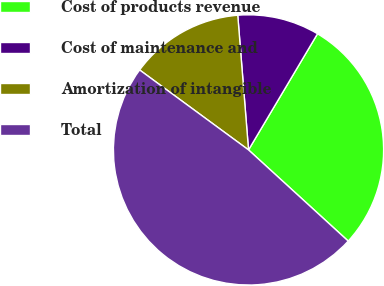<chart> <loc_0><loc_0><loc_500><loc_500><pie_chart><fcel>Cost of products revenue<fcel>Cost of maintenance and<fcel>Amortization of intangible<fcel>Total<nl><fcel>28.26%<fcel>9.8%<fcel>13.65%<fcel>48.29%<nl></chart> 